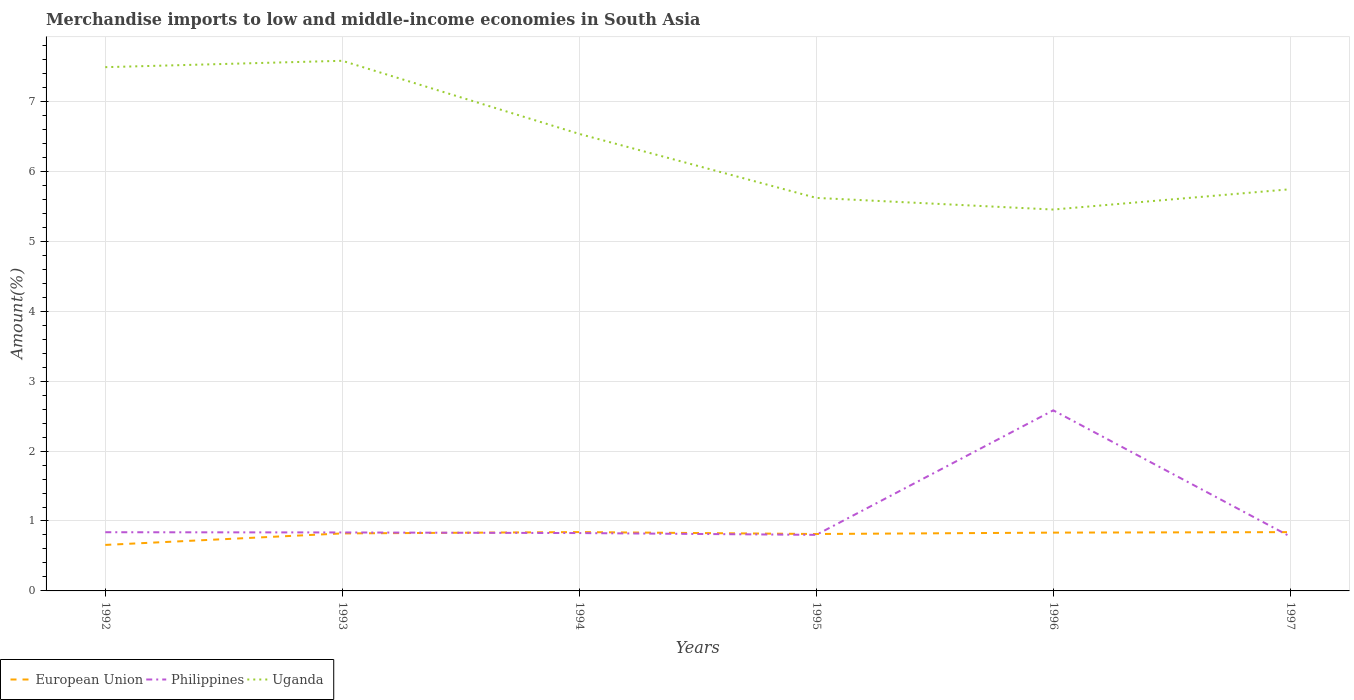How many different coloured lines are there?
Keep it short and to the point. 3. Across all years, what is the maximum percentage of amount earned from merchandise imports in Uganda?
Your answer should be compact. 5.45. What is the total percentage of amount earned from merchandise imports in European Union in the graph?
Your answer should be very brief. -0.02. What is the difference between the highest and the second highest percentage of amount earned from merchandise imports in Philippines?
Your response must be concise. 1.8. What is the difference between the highest and the lowest percentage of amount earned from merchandise imports in Philippines?
Your answer should be very brief. 1. Is the percentage of amount earned from merchandise imports in Philippines strictly greater than the percentage of amount earned from merchandise imports in Uganda over the years?
Provide a short and direct response. Yes. How many years are there in the graph?
Offer a very short reply. 6. Does the graph contain grids?
Give a very brief answer. Yes. Where does the legend appear in the graph?
Provide a short and direct response. Bottom left. How many legend labels are there?
Keep it short and to the point. 3. How are the legend labels stacked?
Provide a short and direct response. Horizontal. What is the title of the graph?
Provide a succinct answer. Merchandise imports to low and middle-income economies in South Asia. Does "Cayman Islands" appear as one of the legend labels in the graph?
Offer a terse response. No. What is the label or title of the X-axis?
Make the answer very short. Years. What is the label or title of the Y-axis?
Provide a succinct answer. Amount(%). What is the Amount(%) of European Union in 1992?
Offer a terse response. 0.66. What is the Amount(%) of Philippines in 1992?
Give a very brief answer. 0.84. What is the Amount(%) in Uganda in 1992?
Your answer should be very brief. 7.49. What is the Amount(%) in European Union in 1993?
Offer a terse response. 0.82. What is the Amount(%) in Philippines in 1993?
Make the answer very short. 0.84. What is the Amount(%) in Uganda in 1993?
Your answer should be very brief. 7.58. What is the Amount(%) in European Union in 1994?
Your answer should be very brief. 0.84. What is the Amount(%) in Philippines in 1994?
Ensure brevity in your answer.  0.83. What is the Amount(%) in Uganda in 1994?
Make the answer very short. 6.54. What is the Amount(%) in European Union in 1995?
Keep it short and to the point. 0.81. What is the Amount(%) in Philippines in 1995?
Your answer should be compact. 0.8. What is the Amount(%) of Uganda in 1995?
Make the answer very short. 5.62. What is the Amount(%) of European Union in 1996?
Your response must be concise. 0.83. What is the Amount(%) in Philippines in 1996?
Make the answer very short. 2.58. What is the Amount(%) of Uganda in 1996?
Your answer should be very brief. 5.45. What is the Amount(%) in European Union in 1997?
Your response must be concise. 0.84. What is the Amount(%) of Philippines in 1997?
Offer a very short reply. 0.78. What is the Amount(%) in Uganda in 1997?
Make the answer very short. 5.74. Across all years, what is the maximum Amount(%) of European Union?
Your answer should be very brief. 0.84. Across all years, what is the maximum Amount(%) of Philippines?
Make the answer very short. 2.58. Across all years, what is the maximum Amount(%) of Uganda?
Ensure brevity in your answer.  7.58. Across all years, what is the minimum Amount(%) of European Union?
Provide a short and direct response. 0.66. Across all years, what is the minimum Amount(%) of Philippines?
Provide a short and direct response. 0.78. Across all years, what is the minimum Amount(%) of Uganda?
Keep it short and to the point. 5.45. What is the total Amount(%) in European Union in the graph?
Make the answer very short. 4.81. What is the total Amount(%) of Philippines in the graph?
Ensure brevity in your answer.  6.67. What is the total Amount(%) in Uganda in the graph?
Keep it short and to the point. 38.43. What is the difference between the Amount(%) in European Union in 1992 and that in 1993?
Provide a succinct answer. -0.16. What is the difference between the Amount(%) in Philippines in 1992 and that in 1993?
Make the answer very short. 0. What is the difference between the Amount(%) in Uganda in 1992 and that in 1993?
Give a very brief answer. -0.09. What is the difference between the Amount(%) in European Union in 1992 and that in 1994?
Offer a very short reply. -0.18. What is the difference between the Amount(%) in Philippines in 1992 and that in 1994?
Provide a succinct answer. 0.01. What is the difference between the Amount(%) in Uganda in 1992 and that in 1994?
Your response must be concise. 0.95. What is the difference between the Amount(%) of European Union in 1992 and that in 1995?
Your answer should be very brief. -0.16. What is the difference between the Amount(%) in Philippines in 1992 and that in 1995?
Provide a short and direct response. 0.04. What is the difference between the Amount(%) of Uganda in 1992 and that in 1995?
Ensure brevity in your answer.  1.87. What is the difference between the Amount(%) in European Union in 1992 and that in 1996?
Offer a very short reply. -0.18. What is the difference between the Amount(%) of Philippines in 1992 and that in 1996?
Provide a short and direct response. -1.74. What is the difference between the Amount(%) in Uganda in 1992 and that in 1996?
Ensure brevity in your answer.  2.04. What is the difference between the Amount(%) in European Union in 1992 and that in 1997?
Keep it short and to the point. -0.18. What is the difference between the Amount(%) in Philippines in 1992 and that in 1997?
Provide a succinct answer. 0.06. What is the difference between the Amount(%) of Uganda in 1992 and that in 1997?
Your answer should be compact. 1.75. What is the difference between the Amount(%) in European Union in 1993 and that in 1994?
Give a very brief answer. -0.02. What is the difference between the Amount(%) of Philippines in 1993 and that in 1994?
Your answer should be very brief. 0.01. What is the difference between the Amount(%) in Uganda in 1993 and that in 1994?
Your answer should be very brief. 1.05. What is the difference between the Amount(%) in European Union in 1993 and that in 1995?
Your response must be concise. 0.01. What is the difference between the Amount(%) of Philippines in 1993 and that in 1995?
Your answer should be compact. 0.03. What is the difference between the Amount(%) in Uganda in 1993 and that in 1995?
Make the answer very short. 1.96. What is the difference between the Amount(%) in European Union in 1993 and that in 1996?
Provide a short and direct response. -0.01. What is the difference between the Amount(%) of Philippines in 1993 and that in 1996?
Ensure brevity in your answer.  -1.75. What is the difference between the Amount(%) in Uganda in 1993 and that in 1996?
Ensure brevity in your answer.  2.13. What is the difference between the Amount(%) in European Union in 1993 and that in 1997?
Ensure brevity in your answer.  -0.02. What is the difference between the Amount(%) in Philippines in 1993 and that in 1997?
Offer a very short reply. 0.06. What is the difference between the Amount(%) of Uganda in 1993 and that in 1997?
Your answer should be very brief. 1.84. What is the difference between the Amount(%) in European Union in 1994 and that in 1995?
Ensure brevity in your answer.  0.03. What is the difference between the Amount(%) of Philippines in 1994 and that in 1995?
Offer a very short reply. 0.03. What is the difference between the Amount(%) of Uganda in 1994 and that in 1995?
Offer a terse response. 0.92. What is the difference between the Amount(%) in European Union in 1994 and that in 1996?
Your answer should be compact. 0.01. What is the difference between the Amount(%) of Philippines in 1994 and that in 1996?
Provide a short and direct response. -1.76. What is the difference between the Amount(%) in Uganda in 1994 and that in 1996?
Offer a very short reply. 1.08. What is the difference between the Amount(%) of European Union in 1994 and that in 1997?
Provide a short and direct response. 0. What is the difference between the Amount(%) in Philippines in 1994 and that in 1997?
Ensure brevity in your answer.  0.05. What is the difference between the Amount(%) of Uganda in 1994 and that in 1997?
Provide a short and direct response. 0.79. What is the difference between the Amount(%) in European Union in 1995 and that in 1996?
Offer a very short reply. -0.02. What is the difference between the Amount(%) of Philippines in 1995 and that in 1996?
Give a very brief answer. -1.78. What is the difference between the Amount(%) of Uganda in 1995 and that in 1996?
Your answer should be compact. 0.17. What is the difference between the Amount(%) of European Union in 1995 and that in 1997?
Your answer should be compact. -0.03. What is the difference between the Amount(%) in Philippines in 1995 and that in 1997?
Provide a short and direct response. 0.02. What is the difference between the Amount(%) in Uganda in 1995 and that in 1997?
Provide a succinct answer. -0.12. What is the difference between the Amount(%) in European Union in 1996 and that in 1997?
Ensure brevity in your answer.  -0.01. What is the difference between the Amount(%) in Philippines in 1996 and that in 1997?
Give a very brief answer. 1.8. What is the difference between the Amount(%) of Uganda in 1996 and that in 1997?
Provide a short and direct response. -0.29. What is the difference between the Amount(%) of European Union in 1992 and the Amount(%) of Philippines in 1993?
Make the answer very short. -0.18. What is the difference between the Amount(%) of European Union in 1992 and the Amount(%) of Uganda in 1993?
Provide a succinct answer. -6.92. What is the difference between the Amount(%) in Philippines in 1992 and the Amount(%) in Uganda in 1993?
Offer a terse response. -6.74. What is the difference between the Amount(%) of European Union in 1992 and the Amount(%) of Philippines in 1994?
Make the answer very short. -0.17. What is the difference between the Amount(%) of European Union in 1992 and the Amount(%) of Uganda in 1994?
Your answer should be compact. -5.88. What is the difference between the Amount(%) of Philippines in 1992 and the Amount(%) of Uganda in 1994?
Give a very brief answer. -5.7. What is the difference between the Amount(%) of European Union in 1992 and the Amount(%) of Philippines in 1995?
Make the answer very short. -0.14. What is the difference between the Amount(%) of European Union in 1992 and the Amount(%) of Uganda in 1995?
Provide a short and direct response. -4.96. What is the difference between the Amount(%) of Philippines in 1992 and the Amount(%) of Uganda in 1995?
Make the answer very short. -4.78. What is the difference between the Amount(%) in European Union in 1992 and the Amount(%) in Philippines in 1996?
Give a very brief answer. -1.92. What is the difference between the Amount(%) of European Union in 1992 and the Amount(%) of Uganda in 1996?
Your answer should be very brief. -4.8. What is the difference between the Amount(%) in Philippines in 1992 and the Amount(%) in Uganda in 1996?
Your answer should be very brief. -4.61. What is the difference between the Amount(%) of European Union in 1992 and the Amount(%) of Philippines in 1997?
Provide a succinct answer. -0.12. What is the difference between the Amount(%) of European Union in 1992 and the Amount(%) of Uganda in 1997?
Your answer should be very brief. -5.09. What is the difference between the Amount(%) in Philippines in 1992 and the Amount(%) in Uganda in 1997?
Your response must be concise. -4.91. What is the difference between the Amount(%) of European Union in 1993 and the Amount(%) of Philippines in 1994?
Provide a succinct answer. -0.01. What is the difference between the Amount(%) of European Union in 1993 and the Amount(%) of Uganda in 1994?
Your answer should be very brief. -5.71. What is the difference between the Amount(%) in Philippines in 1993 and the Amount(%) in Uganda in 1994?
Provide a succinct answer. -5.7. What is the difference between the Amount(%) of European Union in 1993 and the Amount(%) of Philippines in 1995?
Give a very brief answer. 0.02. What is the difference between the Amount(%) of European Union in 1993 and the Amount(%) of Uganda in 1995?
Your answer should be very brief. -4.8. What is the difference between the Amount(%) in Philippines in 1993 and the Amount(%) in Uganda in 1995?
Give a very brief answer. -4.78. What is the difference between the Amount(%) of European Union in 1993 and the Amount(%) of Philippines in 1996?
Make the answer very short. -1.76. What is the difference between the Amount(%) of European Union in 1993 and the Amount(%) of Uganda in 1996?
Your response must be concise. -4.63. What is the difference between the Amount(%) of Philippines in 1993 and the Amount(%) of Uganda in 1996?
Provide a succinct answer. -4.62. What is the difference between the Amount(%) of European Union in 1993 and the Amount(%) of Philippines in 1997?
Keep it short and to the point. 0.04. What is the difference between the Amount(%) of European Union in 1993 and the Amount(%) of Uganda in 1997?
Offer a very short reply. -4.92. What is the difference between the Amount(%) of Philippines in 1993 and the Amount(%) of Uganda in 1997?
Provide a short and direct response. -4.91. What is the difference between the Amount(%) of European Union in 1994 and the Amount(%) of Philippines in 1995?
Give a very brief answer. 0.04. What is the difference between the Amount(%) of European Union in 1994 and the Amount(%) of Uganda in 1995?
Ensure brevity in your answer.  -4.78. What is the difference between the Amount(%) of Philippines in 1994 and the Amount(%) of Uganda in 1995?
Offer a very short reply. -4.79. What is the difference between the Amount(%) in European Union in 1994 and the Amount(%) in Philippines in 1996?
Make the answer very short. -1.74. What is the difference between the Amount(%) in European Union in 1994 and the Amount(%) in Uganda in 1996?
Your answer should be very brief. -4.61. What is the difference between the Amount(%) of Philippines in 1994 and the Amount(%) of Uganda in 1996?
Your response must be concise. -4.63. What is the difference between the Amount(%) in European Union in 1994 and the Amount(%) in Philippines in 1997?
Your response must be concise. 0.06. What is the difference between the Amount(%) of European Union in 1994 and the Amount(%) of Uganda in 1997?
Ensure brevity in your answer.  -4.9. What is the difference between the Amount(%) of Philippines in 1994 and the Amount(%) of Uganda in 1997?
Keep it short and to the point. -4.92. What is the difference between the Amount(%) in European Union in 1995 and the Amount(%) in Philippines in 1996?
Your answer should be compact. -1.77. What is the difference between the Amount(%) in European Union in 1995 and the Amount(%) in Uganda in 1996?
Your answer should be compact. -4.64. What is the difference between the Amount(%) of Philippines in 1995 and the Amount(%) of Uganda in 1996?
Make the answer very short. -4.65. What is the difference between the Amount(%) of European Union in 1995 and the Amount(%) of Philippines in 1997?
Keep it short and to the point. 0.04. What is the difference between the Amount(%) of European Union in 1995 and the Amount(%) of Uganda in 1997?
Make the answer very short. -4.93. What is the difference between the Amount(%) of Philippines in 1995 and the Amount(%) of Uganda in 1997?
Your answer should be compact. -4.94. What is the difference between the Amount(%) in European Union in 1996 and the Amount(%) in Philippines in 1997?
Your answer should be very brief. 0.06. What is the difference between the Amount(%) of European Union in 1996 and the Amount(%) of Uganda in 1997?
Offer a terse response. -4.91. What is the difference between the Amount(%) of Philippines in 1996 and the Amount(%) of Uganda in 1997?
Offer a very short reply. -3.16. What is the average Amount(%) in European Union per year?
Make the answer very short. 0.8. What is the average Amount(%) in Philippines per year?
Keep it short and to the point. 1.11. What is the average Amount(%) in Uganda per year?
Your answer should be compact. 6.4. In the year 1992, what is the difference between the Amount(%) in European Union and Amount(%) in Philippines?
Offer a very short reply. -0.18. In the year 1992, what is the difference between the Amount(%) in European Union and Amount(%) in Uganda?
Your response must be concise. -6.83. In the year 1992, what is the difference between the Amount(%) of Philippines and Amount(%) of Uganda?
Provide a short and direct response. -6.65. In the year 1993, what is the difference between the Amount(%) of European Union and Amount(%) of Philippines?
Your answer should be very brief. -0.01. In the year 1993, what is the difference between the Amount(%) in European Union and Amount(%) in Uganda?
Your answer should be compact. -6.76. In the year 1993, what is the difference between the Amount(%) in Philippines and Amount(%) in Uganda?
Offer a very short reply. -6.75. In the year 1994, what is the difference between the Amount(%) of European Union and Amount(%) of Philippines?
Ensure brevity in your answer.  0.01. In the year 1994, what is the difference between the Amount(%) of European Union and Amount(%) of Uganda?
Provide a short and direct response. -5.69. In the year 1994, what is the difference between the Amount(%) in Philippines and Amount(%) in Uganda?
Provide a short and direct response. -5.71. In the year 1995, what is the difference between the Amount(%) in European Union and Amount(%) in Philippines?
Keep it short and to the point. 0.01. In the year 1995, what is the difference between the Amount(%) in European Union and Amount(%) in Uganda?
Your response must be concise. -4.81. In the year 1995, what is the difference between the Amount(%) in Philippines and Amount(%) in Uganda?
Provide a succinct answer. -4.82. In the year 1996, what is the difference between the Amount(%) in European Union and Amount(%) in Philippines?
Give a very brief answer. -1.75. In the year 1996, what is the difference between the Amount(%) in European Union and Amount(%) in Uganda?
Provide a short and direct response. -4.62. In the year 1996, what is the difference between the Amount(%) of Philippines and Amount(%) of Uganda?
Your response must be concise. -2.87. In the year 1997, what is the difference between the Amount(%) in European Union and Amount(%) in Philippines?
Ensure brevity in your answer.  0.06. In the year 1997, what is the difference between the Amount(%) of European Union and Amount(%) of Uganda?
Provide a short and direct response. -4.9. In the year 1997, what is the difference between the Amount(%) in Philippines and Amount(%) in Uganda?
Keep it short and to the point. -4.97. What is the ratio of the Amount(%) in European Union in 1992 to that in 1993?
Offer a very short reply. 0.8. What is the ratio of the Amount(%) in European Union in 1992 to that in 1994?
Ensure brevity in your answer.  0.78. What is the ratio of the Amount(%) in Philippines in 1992 to that in 1994?
Provide a short and direct response. 1.01. What is the ratio of the Amount(%) in Uganda in 1992 to that in 1994?
Provide a succinct answer. 1.15. What is the ratio of the Amount(%) of European Union in 1992 to that in 1995?
Ensure brevity in your answer.  0.81. What is the ratio of the Amount(%) of Philippines in 1992 to that in 1995?
Give a very brief answer. 1.05. What is the ratio of the Amount(%) in Uganda in 1992 to that in 1995?
Your answer should be compact. 1.33. What is the ratio of the Amount(%) of European Union in 1992 to that in 1996?
Your answer should be very brief. 0.79. What is the ratio of the Amount(%) in Philippines in 1992 to that in 1996?
Your answer should be very brief. 0.33. What is the ratio of the Amount(%) in Uganda in 1992 to that in 1996?
Your response must be concise. 1.37. What is the ratio of the Amount(%) of European Union in 1992 to that in 1997?
Give a very brief answer. 0.78. What is the ratio of the Amount(%) of Philippines in 1992 to that in 1997?
Your response must be concise. 1.08. What is the ratio of the Amount(%) of Uganda in 1992 to that in 1997?
Keep it short and to the point. 1.3. What is the ratio of the Amount(%) of European Union in 1993 to that in 1994?
Offer a very short reply. 0.98. What is the ratio of the Amount(%) in Philippines in 1993 to that in 1994?
Ensure brevity in your answer.  1.01. What is the ratio of the Amount(%) in Uganda in 1993 to that in 1994?
Provide a succinct answer. 1.16. What is the ratio of the Amount(%) in European Union in 1993 to that in 1995?
Give a very brief answer. 1.01. What is the ratio of the Amount(%) in Philippines in 1993 to that in 1995?
Ensure brevity in your answer.  1.04. What is the ratio of the Amount(%) of Uganda in 1993 to that in 1995?
Make the answer very short. 1.35. What is the ratio of the Amount(%) in European Union in 1993 to that in 1996?
Provide a short and direct response. 0.99. What is the ratio of the Amount(%) of Philippines in 1993 to that in 1996?
Provide a succinct answer. 0.32. What is the ratio of the Amount(%) in Uganda in 1993 to that in 1996?
Provide a short and direct response. 1.39. What is the ratio of the Amount(%) in European Union in 1993 to that in 1997?
Keep it short and to the point. 0.98. What is the ratio of the Amount(%) in Philippines in 1993 to that in 1997?
Offer a terse response. 1.08. What is the ratio of the Amount(%) in Uganda in 1993 to that in 1997?
Provide a succinct answer. 1.32. What is the ratio of the Amount(%) of European Union in 1994 to that in 1995?
Your answer should be compact. 1.03. What is the ratio of the Amount(%) of Philippines in 1994 to that in 1995?
Make the answer very short. 1.03. What is the ratio of the Amount(%) in Uganda in 1994 to that in 1995?
Give a very brief answer. 1.16. What is the ratio of the Amount(%) in European Union in 1994 to that in 1996?
Your answer should be compact. 1.01. What is the ratio of the Amount(%) of Philippines in 1994 to that in 1996?
Provide a short and direct response. 0.32. What is the ratio of the Amount(%) in Uganda in 1994 to that in 1996?
Provide a succinct answer. 1.2. What is the ratio of the Amount(%) of European Union in 1994 to that in 1997?
Offer a very short reply. 1. What is the ratio of the Amount(%) in Philippines in 1994 to that in 1997?
Your response must be concise. 1.06. What is the ratio of the Amount(%) in Uganda in 1994 to that in 1997?
Give a very brief answer. 1.14. What is the ratio of the Amount(%) of European Union in 1995 to that in 1996?
Ensure brevity in your answer.  0.98. What is the ratio of the Amount(%) of Philippines in 1995 to that in 1996?
Make the answer very short. 0.31. What is the ratio of the Amount(%) in Uganda in 1995 to that in 1996?
Your answer should be compact. 1.03. What is the ratio of the Amount(%) of European Union in 1995 to that in 1997?
Offer a terse response. 0.97. What is the ratio of the Amount(%) of Philippines in 1995 to that in 1997?
Your answer should be compact. 1.03. What is the ratio of the Amount(%) of Uganda in 1995 to that in 1997?
Keep it short and to the point. 0.98. What is the ratio of the Amount(%) in Philippines in 1996 to that in 1997?
Provide a succinct answer. 3.32. What is the ratio of the Amount(%) of Uganda in 1996 to that in 1997?
Give a very brief answer. 0.95. What is the difference between the highest and the second highest Amount(%) of European Union?
Offer a very short reply. 0. What is the difference between the highest and the second highest Amount(%) of Philippines?
Ensure brevity in your answer.  1.74. What is the difference between the highest and the second highest Amount(%) of Uganda?
Provide a succinct answer. 0.09. What is the difference between the highest and the lowest Amount(%) in European Union?
Ensure brevity in your answer.  0.18. What is the difference between the highest and the lowest Amount(%) in Philippines?
Your answer should be compact. 1.8. What is the difference between the highest and the lowest Amount(%) in Uganda?
Offer a very short reply. 2.13. 